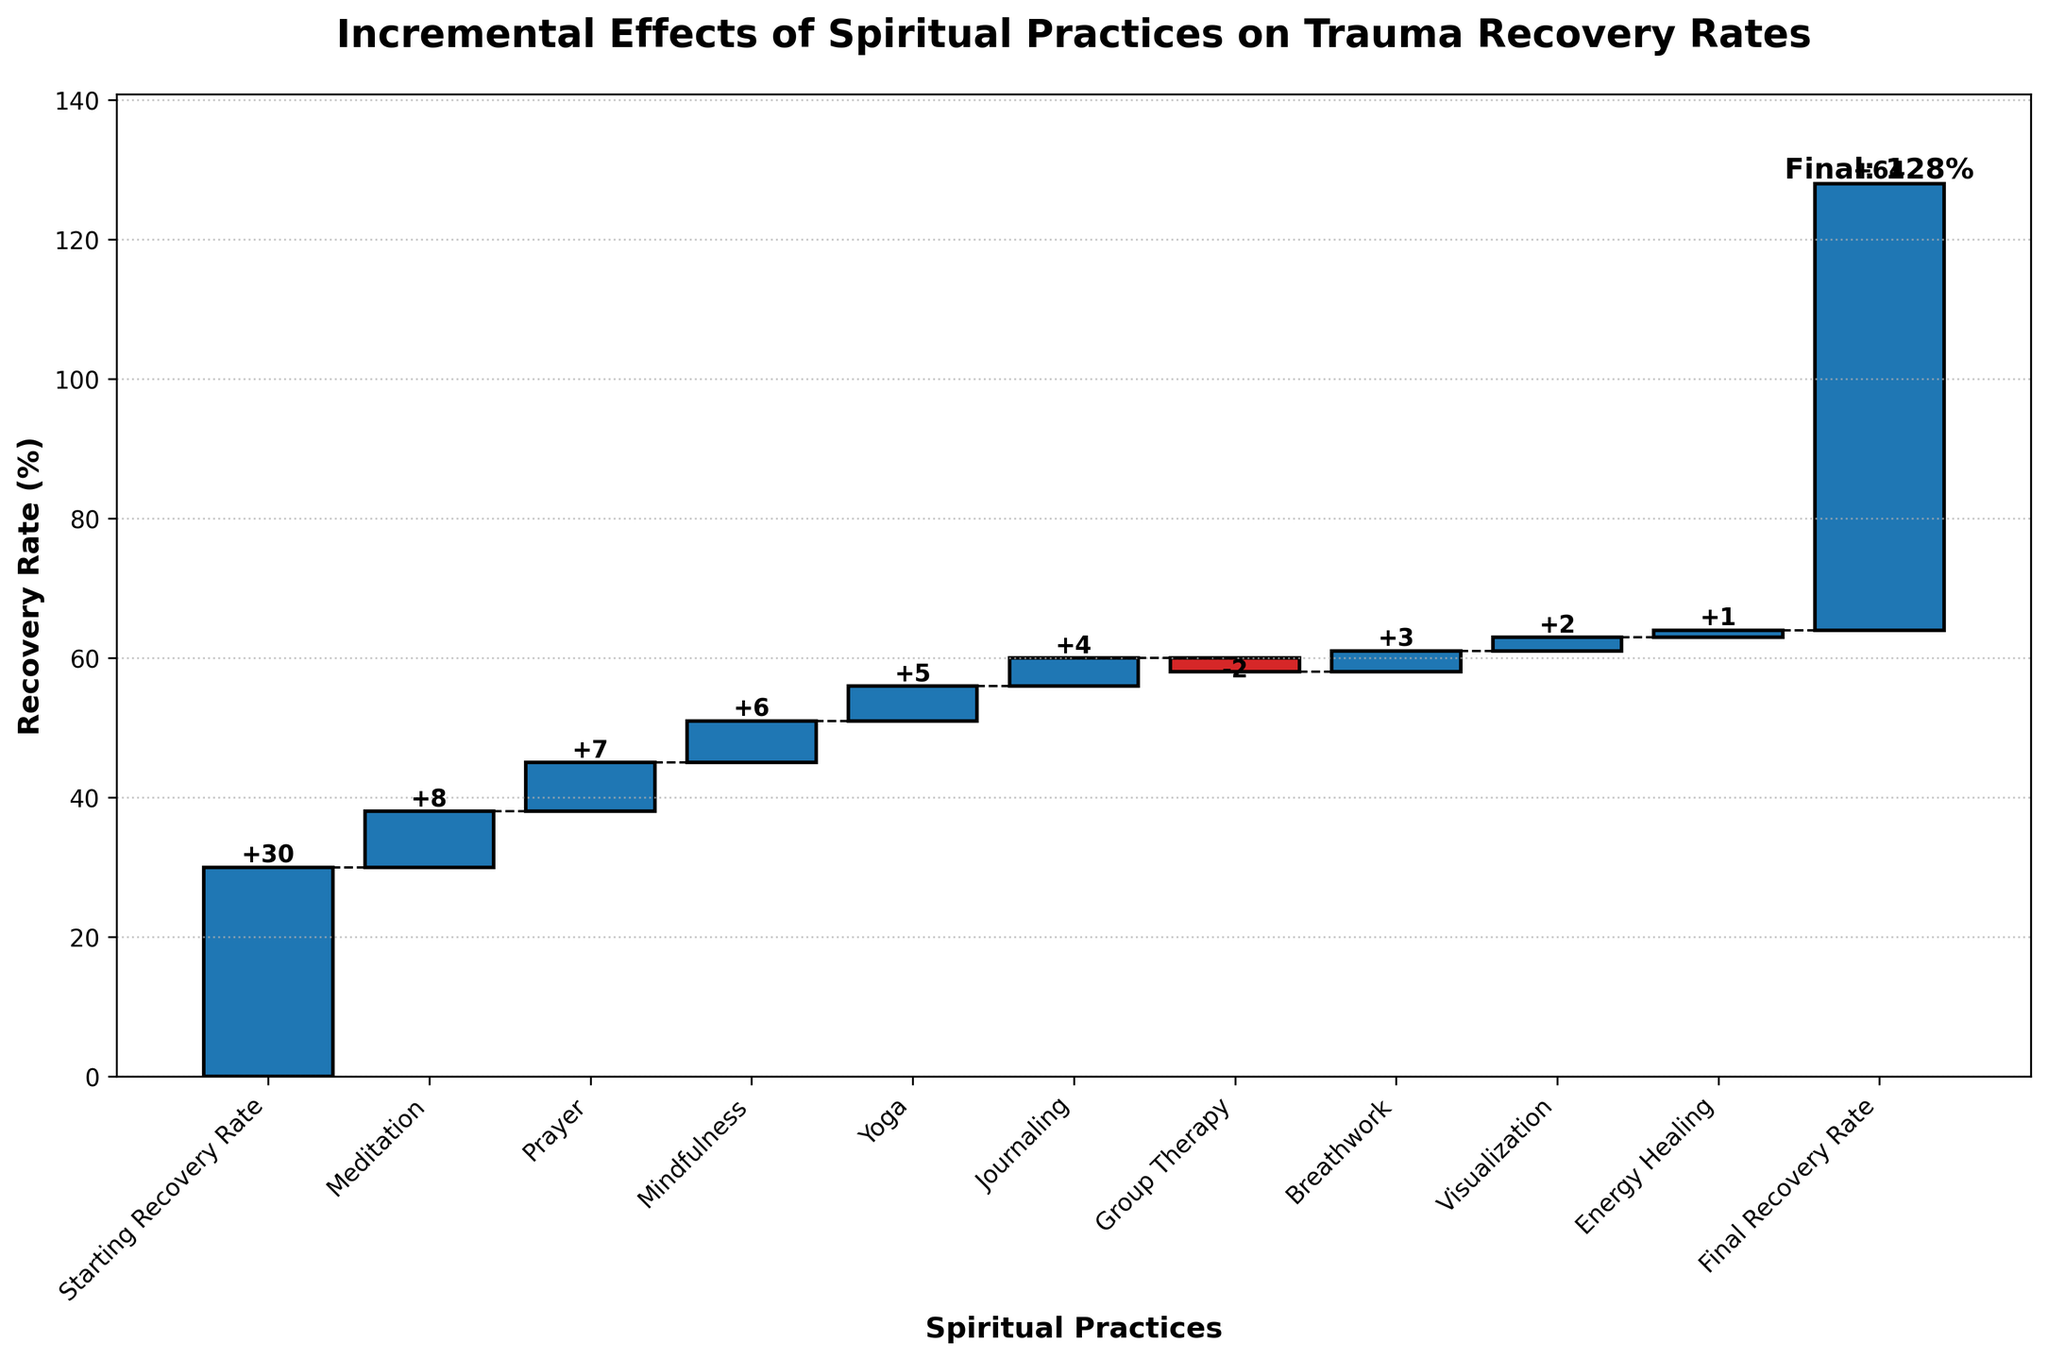What's the title of the plot? The title is displayed at the top of the plot and reads "Incremental Effects of Spiritual Practices on Trauma Recovery Rates".
Answer: Incremental Effects of Spiritual Practices on Trauma Recovery Rates What is the starting recovery rate? The starting recovery rate is listed as the first bar in the chart, labelled "Starting Recovery Rate", and the value is 30%.
Answer: 30% How much does meditation contribute to the recovery rate? The effect of meditation on the recovery rate is shown as "+8" on the corresponding bar of the waterfall chart.
Answer: +8 Which practice has a negative effect on the recovery rate? Group Therapy is the only practice represented in red, indicating a decrement, and it has an effect of -2.
Answer: Group Therapy What's the final recovery rate shown in the chart? The final recovery rate is indicated on the last bar with the label "Final Recovery Rate" and the value is 64%.
Answer: 64% What is the combined effect of Prayer and Mindfulness on trauma recovery? The prayer adds +7 and mindfulness adds +6, so their combined effect is 7 + 6 = 13.
Answer: +13 Between Yoga and Group Therapy, which contributes more positively to the recovery rate? Yoga contributes +5, while Group Therapy has a negative contribution of -2. Thus, Yoga has a more positive effect.
Answer: Yoga What is the average effect of Meditation, Prayer, and Visualization on recovery? Meditation adds +8, Prayer adds +7, and Visualization adds +2. Their total sum is 8 + 7 + 2 = 17. There are 3 elements, so the average effect is 17/3 = 5.67.
Answer: 5.67 Which practice increases the recovery rate by the smallest positive amount? Among the positive contributions, Energy Healing has the smallest value, which is +1.
Answer: Energy Healing Excluding the starting and final recovery rates, what is the total increment contributed by all practices? The increments from Meditation, Prayer, Mindfulness, Yoga, Journaling, Breathwork, and Visualization are 8, 7, 6, 5, 4, 3, 2, and 1 respectively. Their total is 8 + 7 + 6 + 5 + 4 + 3 + 2 + 1 = 36.
Answer: 36 